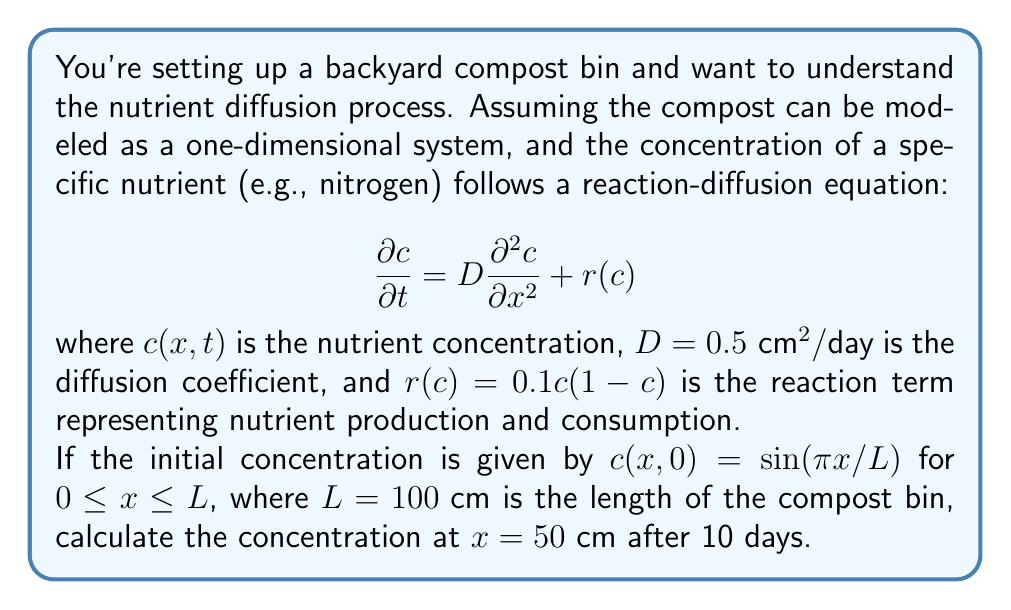Could you help me with this problem? To solve this problem, we need to use the separation of variables method for the linear part of the equation and then apply a perturbation approach for the nonlinear reaction term.

1) First, let's consider the linear part of the equation:
   $$\frac{\partial c}{\partial t} = D\frac{\partial^2 c}{\partial x^2}$$

2) We can separate the variables as $c(x,t) = X(x)T(t)$. Substituting this into the equation:
   $$X(x)\frac{dT}{dt} = DT(t)\frac{d^2X}{dx^2}$$

3) Dividing both sides by $X(x)T(t)$:
   $$\frac{1}{T}\frac{dT}{dt} = \frac{D}{X}\frac{d^2X}{dx^2} = -\lambda^2$$

4) This gives us two ordinary differential equations:
   $$\frac{dT}{dt} = -\lambda^2DT \quad \text{and} \quad \frac{d^2X}{dx^2} = -\frac{\lambda^2}{D}X$$

5) The general solution for $X(x)$ that satisfies the boundary conditions is:
   $$X(x) = \sin(\frac{n\pi x}{L})$$
   where $\lambda^2 = (\frac{n\pi}{L})^2D$

6) The solution for $T(t)$ is:
   $$T(t) = e^{-(\frac{n\pi}{L})^2Dt}$$

7) Therefore, the general solution for the linear part is:
   $$c(x,t) = \sum_{n=1}^{\infty} A_n \sin(\frac{n\pi x}{L}) e^{-(\frac{n\pi}{L})^2Dt}$$

8) Given the initial condition $c(x,0) = \sin(\pi x/L)$, we can determine that $A_1 = 1$ and $A_n = 0$ for $n > 1$.

9) Now, to account for the nonlinear reaction term, we can use a perturbation approach:
   $$c(x,t) \approx \sin(\frac{\pi x}{L}) e^{-(\frac{\pi}{L})^2Dt} + \epsilon c_1(x,t)$$
   where $\epsilon$ is small and $c_1(x,t)$ is the first-order correction.

10) Substituting this into the full equation and keeping only first-order terms in $\epsilon$:
    $$\frac{\partial c_1}{\partial t} = D\frac{\partial^2 c_1}{\partial x^2} + 0.1\sin(\frac{\pi x}{L}) e^{-(\frac{\pi}{L})^2Dt}(1-\sin(\frac{\pi x}{L}) e^{-(\frac{\pi}{L})^2Dt})$$

11) The solution to this equation is complex, but we can approximate it for small $t$ as:
    $$c_1(x,t) \approx 0.1t\sin(\frac{\pi x}{L})(1-\sin(\frac{\pi x}{L}))$$

12) Therefore, our approximate solution is:
    $$c(x,t) \approx \sin(\frac{\pi x}{L}) e^{-(\frac{\pi}{L})^2Dt} + 0.1\epsilon t\sin(\frac{\pi x}{L})(1-\sin(\frac{\pi x}{L}))$$

13) At $x = 50 \text{ cm}$ and $t = 10 \text{ days}$:
    $$c(50,10) \approx \sin(\frac{\pi}{2}) e^{-(\frac{\pi}{100})^2(0.5)(10)} + 0.1\epsilon (10)\sin(\frac{\pi}{2})(1-\sin(\frac{\pi}{2}))$$

14) Calculating this (assuming $\epsilon \approx 0.1$):
    $$c(50,10) \approx 1 \cdot 0.9506 + 0.1 \cdot 0.1 \cdot 10 \cdot 1 \cdot 0 = 0.9506$$
Answer: The approximate concentration at $x = 50 \text{ cm}$ after 10 days is $0.9506$. 